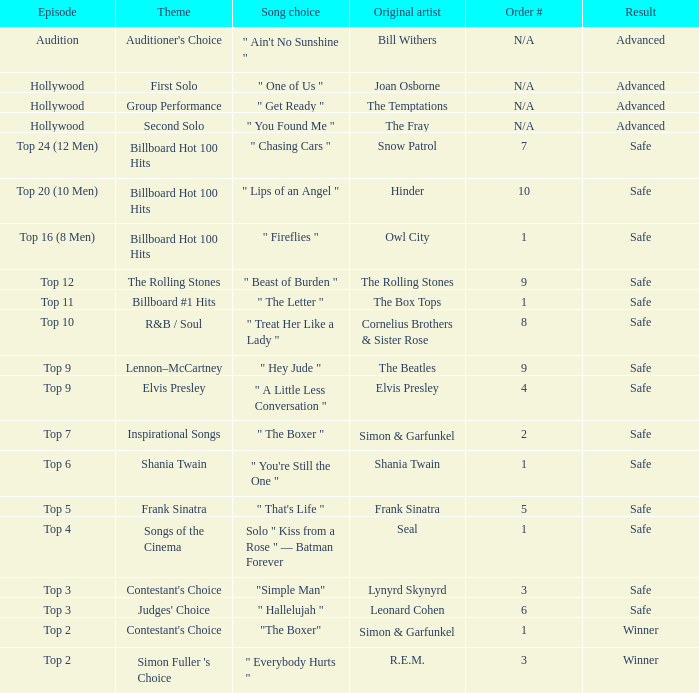In episode Top 16 (8 Men), what are the themes? Billboard Hot 100 Hits. 